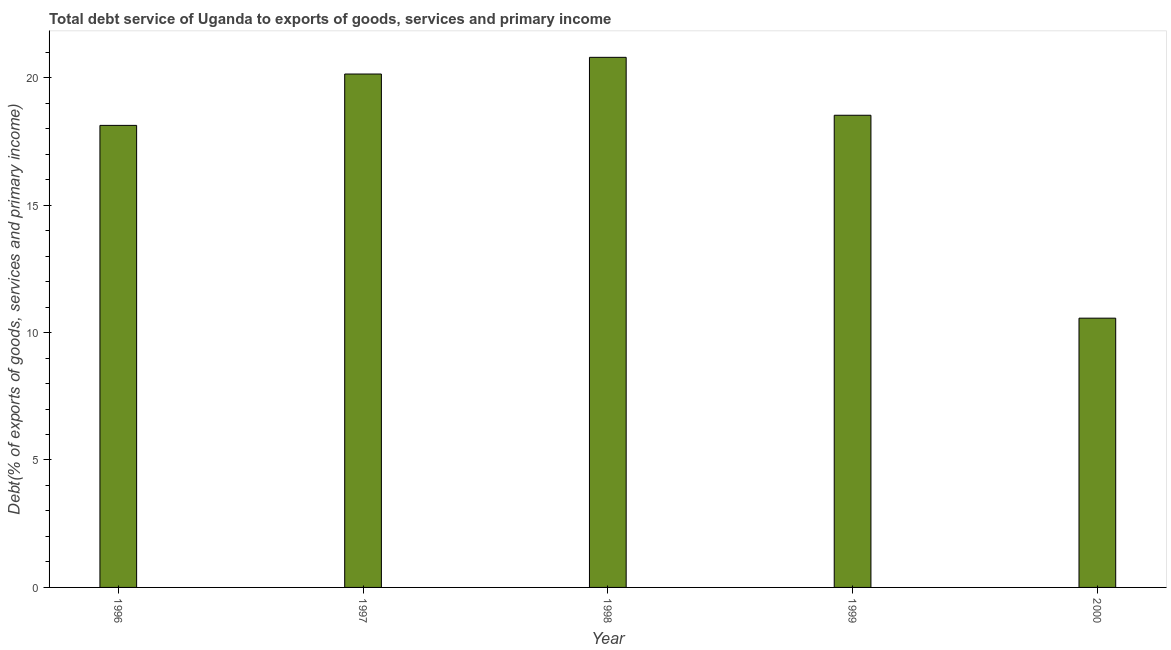Does the graph contain grids?
Provide a short and direct response. No. What is the title of the graph?
Provide a succinct answer. Total debt service of Uganda to exports of goods, services and primary income. What is the label or title of the Y-axis?
Provide a short and direct response. Debt(% of exports of goods, services and primary income). What is the total debt service in 2000?
Ensure brevity in your answer.  10.56. Across all years, what is the maximum total debt service?
Give a very brief answer. 20.8. Across all years, what is the minimum total debt service?
Provide a short and direct response. 10.56. In which year was the total debt service maximum?
Your answer should be very brief. 1998. In which year was the total debt service minimum?
Offer a very short reply. 2000. What is the sum of the total debt service?
Provide a succinct answer. 88.15. What is the difference between the total debt service in 1997 and 2000?
Provide a succinct answer. 9.58. What is the average total debt service per year?
Offer a very short reply. 17.63. What is the median total debt service?
Your answer should be very brief. 18.52. In how many years, is the total debt service greater than 10 %?
Keep it short and to the point. 5. What is the ratio of the total debt service in 1997 to that in 2000?
Make the answer very short. 1.91. Is the total debt service in 1997 less than that in 2000?
Provide a succinct answer. No. Is the difference between the total debt service in 1996 and 2000 greater than the difference between any two years?
Your answer should be compact. No. What is the difference between the highest and the second highest total debt service?
Offer a very short reply. 0.66. What is the difference between the highest and the lowest total debt service?
Offer a terse response. 10.23. In how many years, is the total debt service greater than the average total debt service taken over all years?
Ensure brevity in your answer.  4. How many bars are there?
Provide a short and direct response. 5. Are all the bars in the graph horizontal?
Give a very brief answer. No. What is the Debt(% of exports of goods, services and primary income) in 1996?
Offer a very short reply. 18.13. What is the Debt(% of exports of goods, services and primary income) in 1997?
Make the answer very short. 20.14. What is the Debt(% of exports of goods, services and primary income) of 1998?
Your response must be concise. 20.8. What is the Debt(% of exports of goods, services and primary income) in 1999?
Provide a short and direct response. 18.52. What is the Debt(% of exports of goods, services and primary income) of 2000?
Provide a short and direct response. 10.56. What is the difference between the Debt(% of exports of goods, services and primary income) in 1996 and 1997?
Your response must be concise. -2.02. What is the difference between the Debt(% of exports of goods, services and primary income) in 1996 and 1998?
Provide a short and direct response. -2.67. What is the difference between the Debt(% of exports of goods, services and primary income) in 1996 and 1999?
Your answer should be very brief. -0.4. What is the difference between the Debt(% of exports of goods, services and primary income) in 1996 and 2000?
Provide a succinct answer. 7.56. What is the difference between the Debt(% of exports of goods, services and primary income) in 1997 and 1998?
Make the answer very short. -0.65. What is the difference between the Debt(% of exports of goods, services and primary income) in 1997 and 1999?
Offer a terse response. 1.62. What is the difference between the Debt(% of exports of goods, services and primary income) in 1997 and 2000?
Offer a very short reply. 9.58. What is the difference between the Debt(% of exports of goods, services and primary income) in 1998 and 1999?
Your response must be concise. 2.27. What is the difference between the Debt(% of exports of goods, services and primary income) in 1998 and 2000?
Ensure brevity in your answer.  10.23. What is the difference between the Debt(% of exports of goods, services and primary income) in 1999 and 2000?
Your answer should be compact. 7.96. What is the ratio of the Debt(% of exports of goods, services and primary income) in 1996 to that in 1997?
Make the answer very short. 0.9. What is the ratio of the Debt(% of exports of goods, services and primary income) in 1996 to that in 1998?
Ensure brevity in your answer.  0.87. What is the ratio of the Debt(% of exports of goods, services and primary income) in 1996 to that in 2000?
Provide a succinct answer. 1.72. What is the ratio of the Debt(% of exports of goods, services and primary income) in 1997 to that in 1999?
Your response must be concise. 1.09. What is the ratio of the Debt(% of exports of goods, services and primary income) in 1997 to that in 2000?
Your response must be concise. 1.91. What is the ratio of the Debt(% of exports of goods, services and primary income) in 1998 to that in 1999?
Offer a very short reply. 1.12. What is the ratio of the Debt(% of exports of goods, services and primary income) in 1998 to that in 2000?
Keep it short and to the point. 1.97. What is the ratio of the Debt(% of exports of goods, services and primary income) in 1999 to that in 2000?
Offer a terse response. 1.75. 